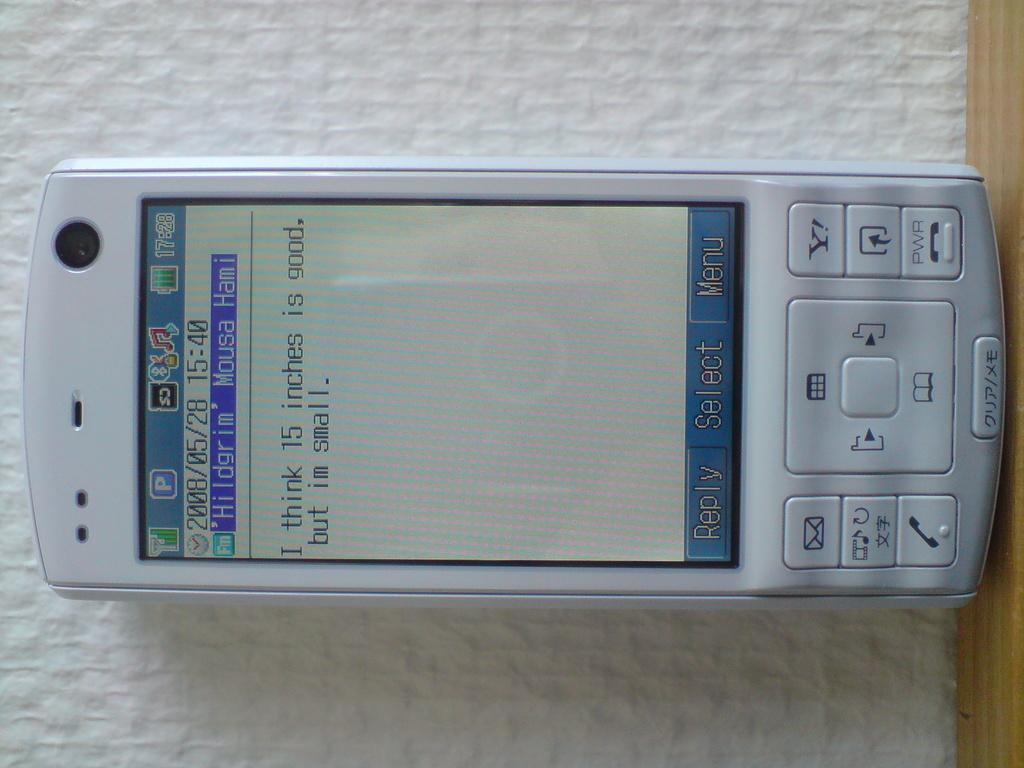<image>
Summarize the visual content of the image. a phone with 15:40 as the time on it 